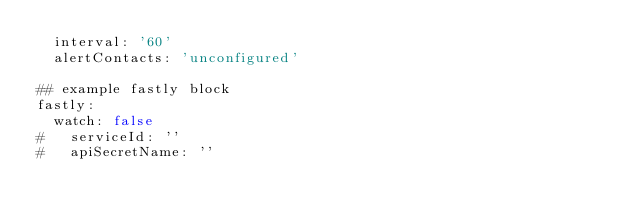<code> <loc_0><loc_0><loc_500><loc_500><_YAML_>  interval: '60'
  alertContacts: 'unconfigured'

## example fastly block
fastly:
  watch: false
#   serviceId: ''
#   apiSecretName: ''</code> 